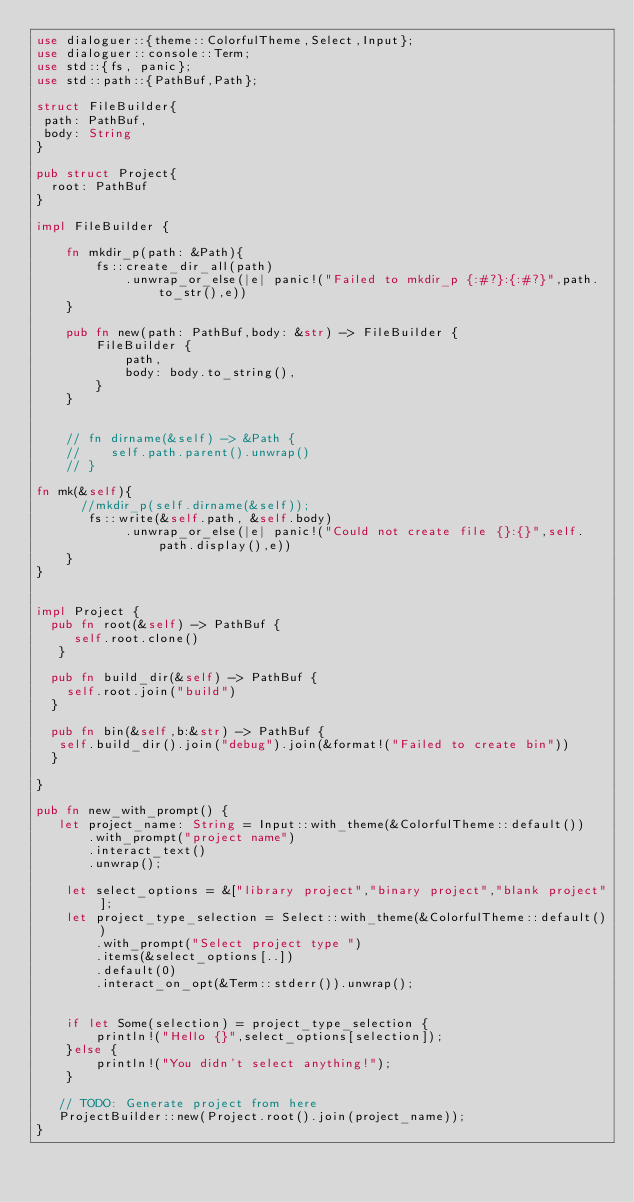Convert code to text. <code><loc_0><loc_0><loc_500><loc_500><_Rust_>use dialoguer::{theme::ColorfulTheme,Select,Input};
use dialoguer::console::Term;
use std::{fs, panic};
use std::path::{PathBuf,Path};

struct FileBuilder{
 path: PathBuf,
 body: String
}

pub struct Project{
  root: PathBuf
}

impl FileBuilder {
    
    fn mkdir_p(path: &Path){
        fs::create_dir_all(path)
            .unwrap_or_else(|e| panic!("Failed to mkdir_p {:#?}:{:#?}",path.to_str(),e))
    }

    pub fn new(path: PathBuf,body: &str) -> FileBuilder {
        FileBuilder {
            path,
            body: body.to_string(),
        }
    }
    

    // fn dirname(&self) -> &Path {
    //    self.path.parent().unwrap()
    // }

fn mk(&self){
      //mkdir_p(self.dirname(&self));
       fs::write(&self.path, &self.body)
            .unwrap_or_else(|e| panic!("Could not create file {}:{}",self.path.display(),e))
    }
}


impl Project {
  pub fn root(&self) -> PathBuf {
     self.root.clone()
   }

  pub fn build_dir(&self) -> PathBuf {
    self.root.join("build")
  }

  pub fn bin(&self,b:&str) -> PathBuf {
   self.build_dir().join("debug").join(&format!("Failed to create bin"))
  }

}

pub fn new_with_prompt() {
   let project_name: String = Input::with_theme(&ColorfulTheme::default())
       .with_prompt("project name")
       .interact_text()
       .unwrap();

    let select_options = &["library project","binary project","blank project"];
    let project_type_selection = Select::with_theme(&ColorfulTheme::default())
        .with_prompt("Select project type ")
        .items(&select_options[..])
        .default(0)
        .interact_on_opt(&Term::stderr()).unwrap();


    if let Some(selection) = project_type_selection {
        println!("Hello {}",select_options[selection]);
    }else {
        println!("You didn't select anything!");
    } 

   // TODO: Generate project from here
   ProjectBuilder::new(Project.root().join(project_name));    
}
</code> 